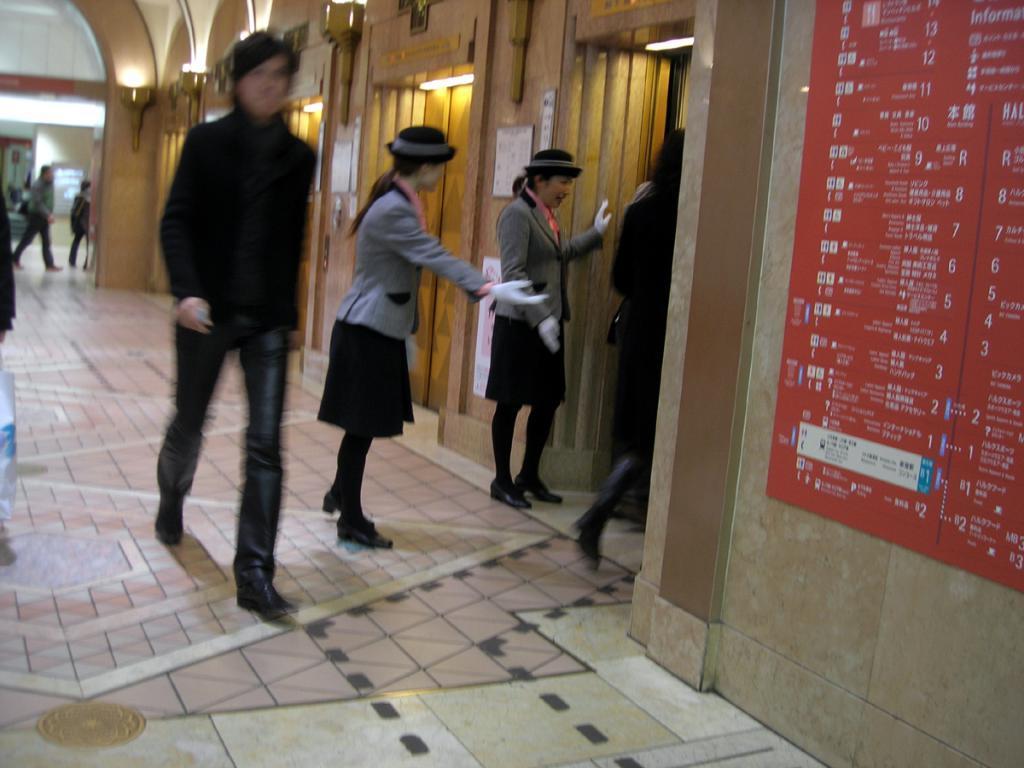Could you give a brief overview of what you see in this image? In this image in the front on the right side there is a board with some text and numbers written on it. In the center there are persons walking and standing. In the background there are lights and there are persons walking and there is a wall. 